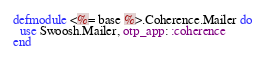Convert code to text. <code><loc_0><loc_0><loc_500><loc_500><_Elixir_>defmodule <%= base %>.Coherence.Mailer do
  use Swoosh.Mailer, otp_app: :coherence
end
</code> 